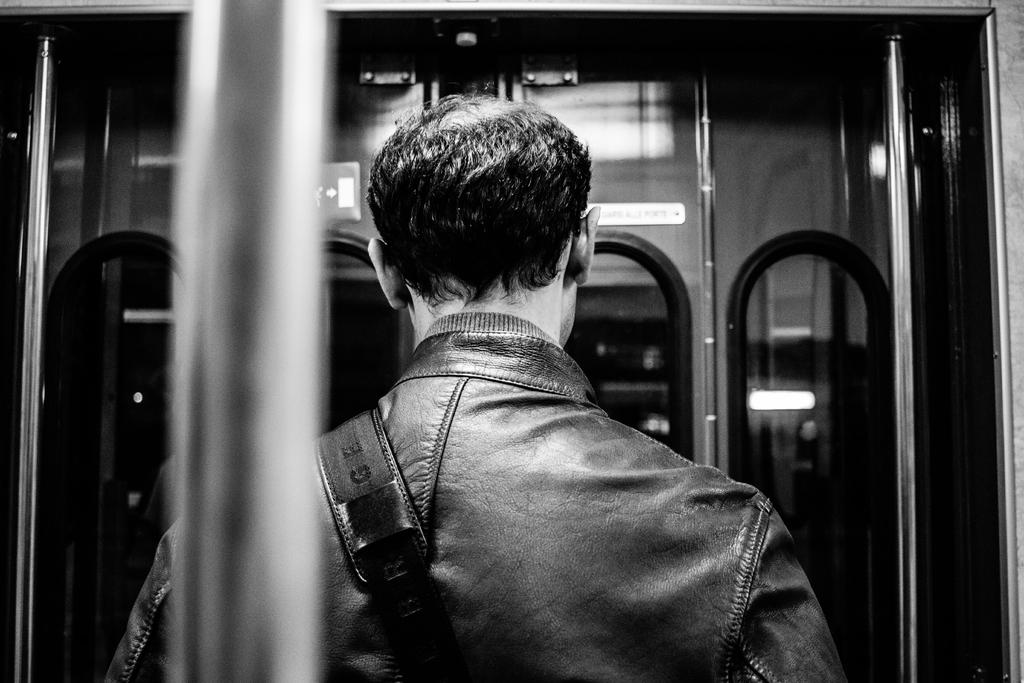Who or what is present in the image? There is a person in the image. What is the person wearing? The person is wearing a bag. What objects are in front of the person? There are mirrors in front of the person. What architectural features can be seen in the image? There are poles visible in the image. What type of humor can be seen in the person's minute expression in the image? There is no humor or expression mentioned in the provided facts, and the person's expression cannot be determined from the image. 